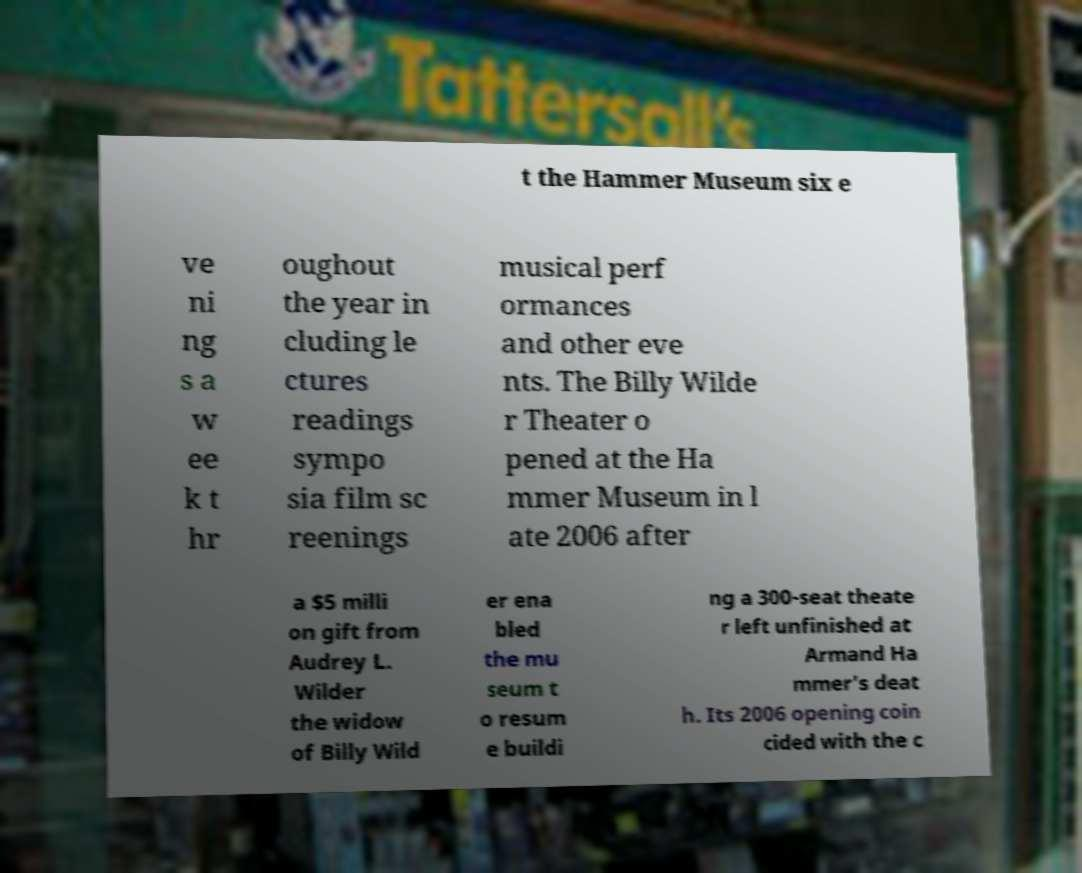For documentation purposes, I need the text within this image transcribed. Could you provide that? t the Hammer Museum six e ve ni ng s a w ee k t hr oughout the year in cluding le ctures readings sympo sia film sc reenings musical perf ormances and other eve nts. The Billy Wilde r Theater o pened at the Ha mmer Museum in l ate 2006 after a $5 milli on gift from Audrey L. Wilder the widow of Billy Wild er ena bled the mu seum t o resum e buildi ng a 300-seat theate r left unfinished at Armand Ha mmer's deat h. Its 2006 opening coin cided with the c 